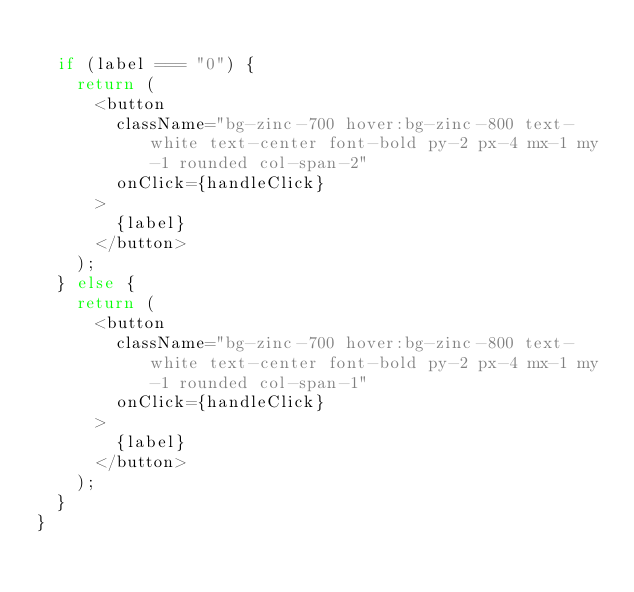Convert code to text. <code><loc_0><loc_0><loc_500><loc_500><_TypeScript_>
  if (label === "0") {
    return (
      <button
        className="bg-zinc-700 hover:bg-zinc-800 text-white text-center font-bold py-2 px-4 mx-1 my-1 rounded col-span-2"
        onClick={handleClick}
      >
        {label}
      </button>
    );
  } else {
    return (
      <button
        className="bg-zinc-700 hover:bg-zinc-800 text-white text-center font-bold py-2 px-4 mx-1 my-1 rounded col-span-1"
        onClick={handleClick}
      >
        {label}
      </button>
    );
  }
}
</code> 